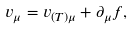<formula> <loc_0><loc_0><loc_500><loc_500>v _ { \mu } = v _ { ( T ) \mu } + \partial _ { \mu } f ,</formula> 